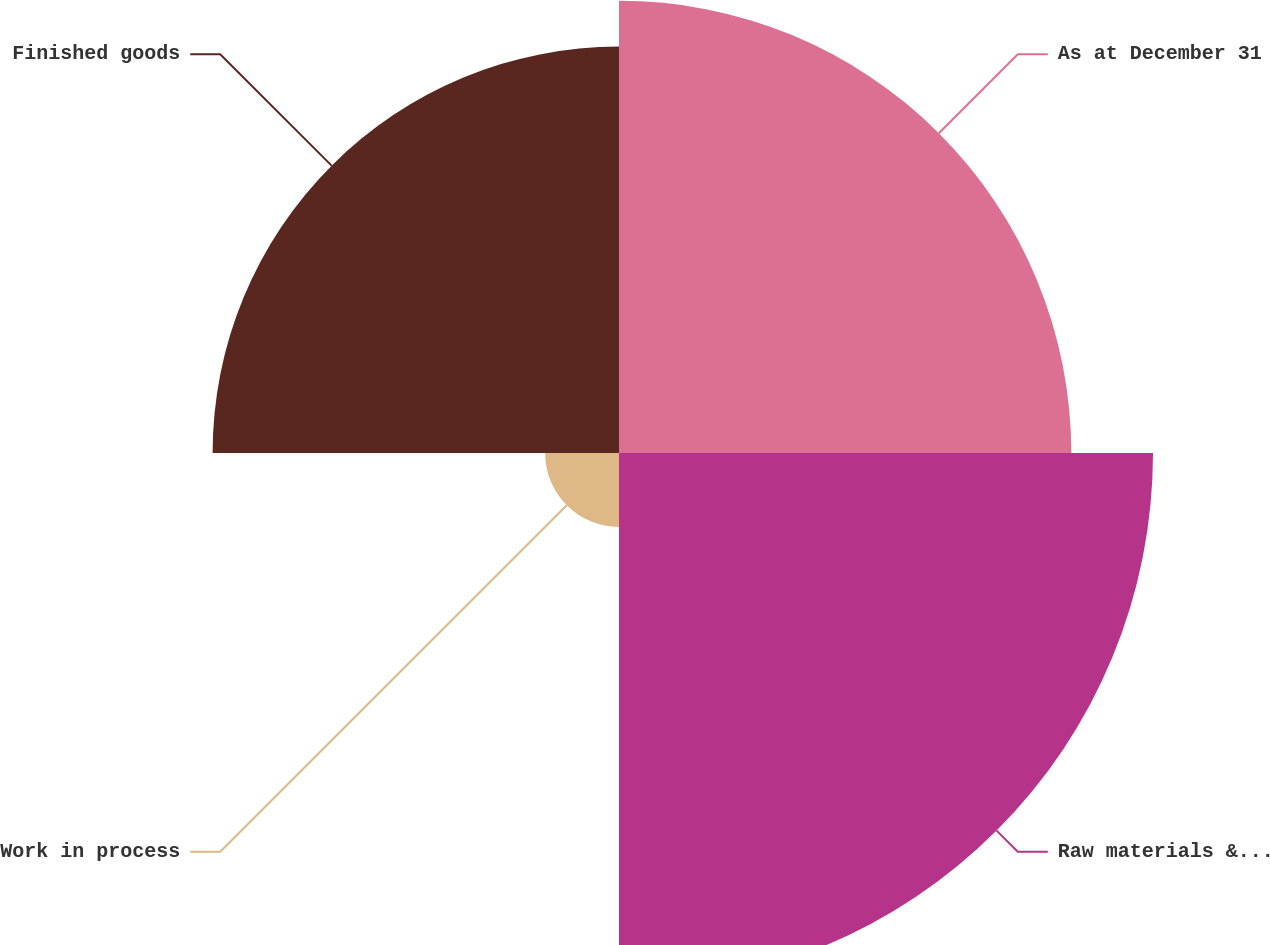Convert chart. <chart><loc_0><loc_0><loc_500><loc_500><pie_chart><fcel>As at December 31<fcel>Raw materials & field<fcel>Work in process<fcel>Finished goods<nl><fcel>30.84%<fcel>36.41%<fcel>5.04%<fcel>27.71%<nl></chart> 